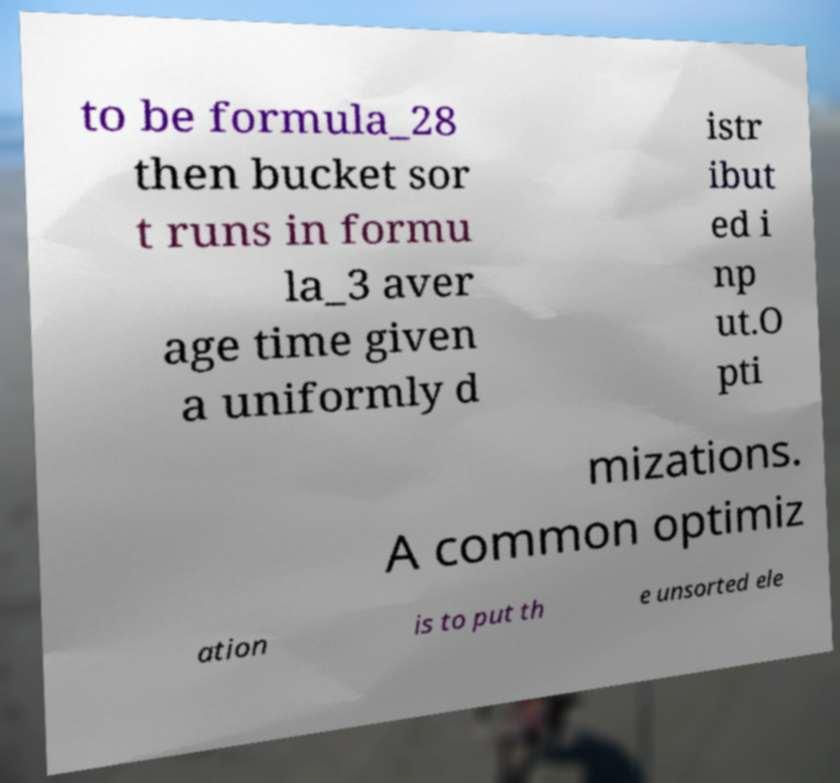Please read and relay the text visible in this image. What does it say? to be formula_28 then bucket sor t runs in formu la_3 aver age time given a uniformly d istr ibut ed i np ut.O pti mizations. A common optimiz ation is to put th e unsorted ele 